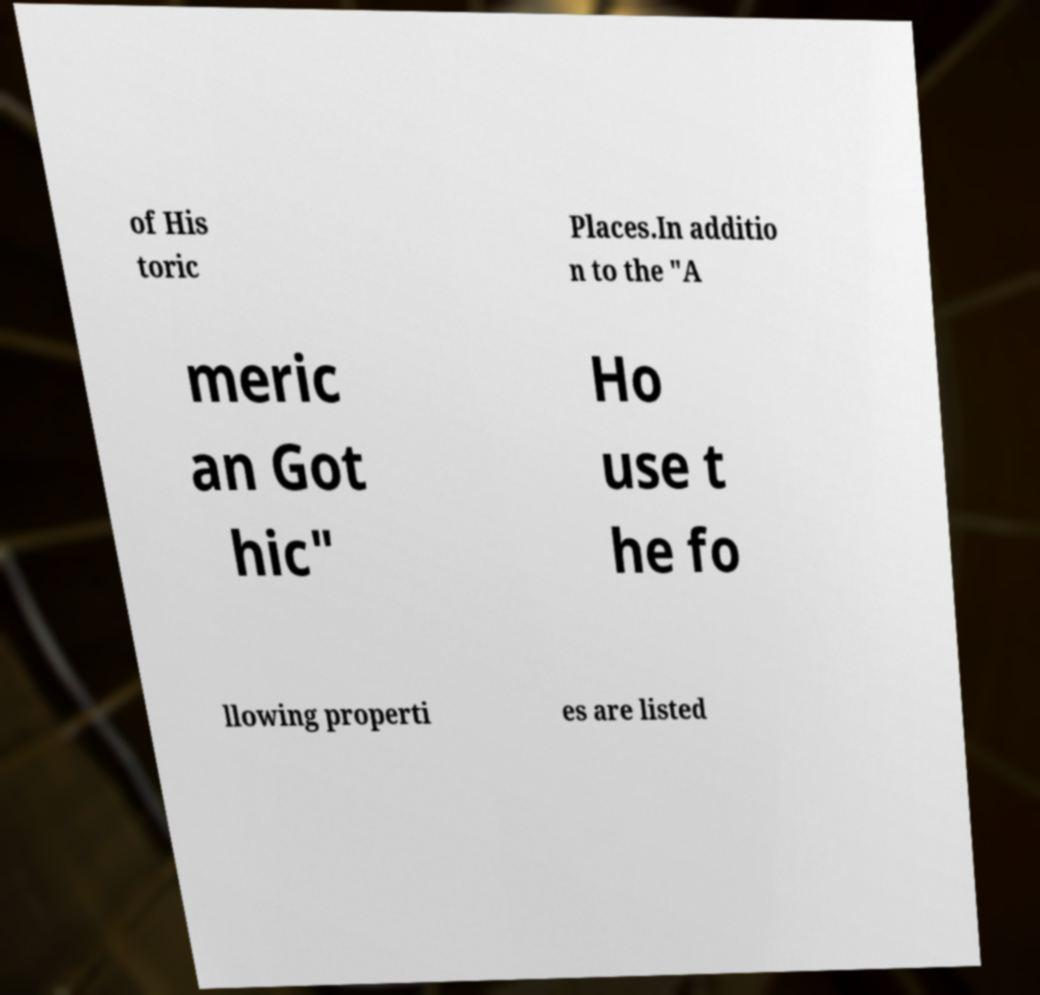For documentation purposes, I need the text within this image transcribed. Could you provide that? of His toric Places.In additio n to the "A meric an Got hic" Ho use t he fo llowing properti es are listed 